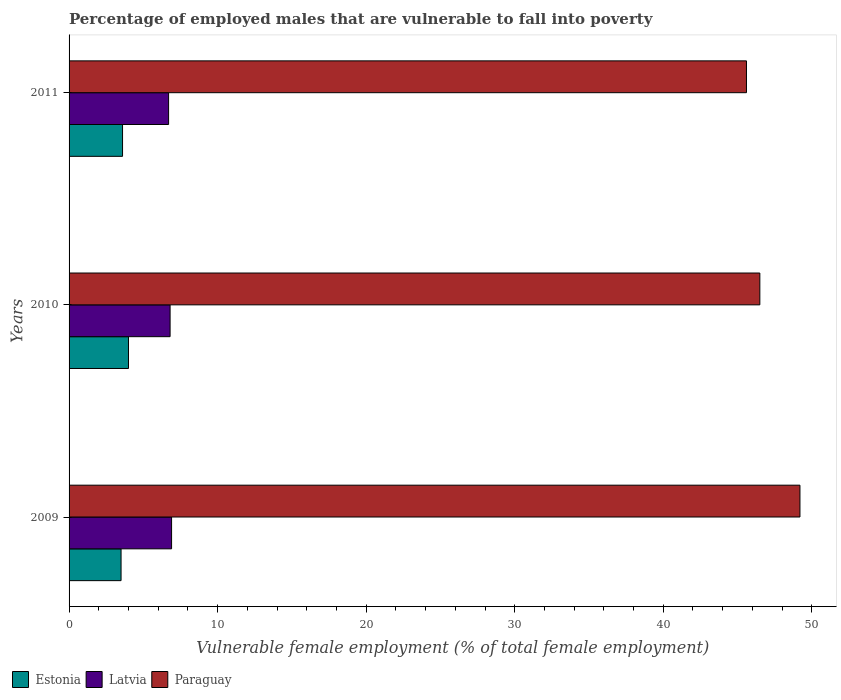How many different coloured bars are there?
Your answer should be very brief. 3. How many groups of bars are there?
Provide a succinct answer. 3. How many bars are there on the 2nd tick from the top?
Your answer should be compact. 3. How many bars are there on the 1st tick from the bottom?
Keep it short and to the point. 3. What is the percentage of employed males who are vulnerable to fall into poverty in Estonia in 2011?
Provide a short and direct response. 3.6. Across all years, what is the maximum percentage of employed males who are vulnerable to fall into poverty in Paraguay?
Offer a very short reply. 49.2. In which year was the percentage of employed males who are vulnerable to fall into poverty in Paraguay maximum?
Your answer should be very brief. 2009. In which year was the percentage of employed males who are vulnerable to fall into poverty in Estonia minimum?
Your answer should be compact. 2009. What is the total percentage of employed males who are vulnerable to fall into poverty in Latvia in the graph?
Your answer should be very brief. 20.4. What is the difference between the percentage of employed males who are vulnerable to fall into poverty in Latvia in 2010 and that in 2011?
Your answer should be very brief. 0.1. What is the difference between the percentage of employed males who are vulnerable to fall into poverty in Paraguay in 2010 and the percentage of employed males who are vulnerable to fall into poverty in Latvia in 2009?
Give a very brief answer. 39.6. What is the average percentage of employed males who are vulnerable to fall into poverty in Estonia per year?
Your response must be concise. 3.7. In the year 2009, what is the difference between the percentage of employed males who are vulnerable to fall into poverty in Estonia and percentage of employed males who are vulnerable to fall into poverty in Latvia?
Keep it short and to the point. -3.4. What is the ratio of the percentage of employed males who are vulnerable to fall into poverty in Latvia in 2009 to that in 2010?
Your answer should be very brief. 1.01. Is the percentage of employed males who are vulnerable to fall into poverty in Estonia in 2010 less than that in 2011?
Ensure brevity in your answer.  No. What is the difference between the highest and the second highest percentage of employed males who are vulnerable to fall into poverty in Latvia?
Ensure brevity in your answer.  0.1. What is the difference between the highest and the lowest percentage of employed males who are vulnerable to fall into poverty in Latvia?
Your response must be concise. 0.2. Is the sum of the percentage of employed males who are vulnerable to fall into poverty in Paraguay in 2010 and 2011 greater than the maximum percentage of employed males who are vulnerable to fall into poverty in Estonia across all years?
Provide a succinct answer. Yes. What does the 3rd bar from the top in 2010 represents?
Provide a short and direct response. Estonia. What does the 1st bar from the bottom in 2010 represents?
Provide a short and direct response. Estonia. How many years are there in the graph?
Offer a terse response. 3. Are the values on the major ticks of X-axis written in scientific E-notation?
Keep it short and to the point. No. Does the graph contain grids?
Provide a succinct answer. No. What is the title of the graph?
Ensure brevity in your answer.  Percentage of employed males that are vulnerable to fall into poverty. Does "Switzerland" appear as one of the legend labels in the graph?
Keep it short and to the point. No. What is the label or title of the X-axis?
Make the answer very short. Vulnerable female employment (% of total female employment). What is the Vulnerable female employment (% of total female employment) of Latvia in 2009?
Your response must be concise. 6.9. What is the Vulnerable female employment (% of total female employment) of Paraguay in 2009?
Your answer should be compact. 49.2. What is the Vulnerable female employment (% of total female employment) of Estonia in 2010?
Offer a very short reply. 4. What is the Vulnerable female employment (% of total female employment) in Latvia in 2010?
Offer a terse response. 6.8. What is the Vulnerable female employment (% of total female employment) in Paraguay in 2010?
Your answer should be very brief. 46.5. What is the Vulnerable female employment (% of total female employment) in Estonia in 2011?
Keep it short and to the point. 3.6. What is the Vulnerable female employment (% of total female employment) of Latvia in 2011?
Your answer should be very brief. 6.7. What is the Vulnerable female employment (% of total female employment) in Paraguay in 2011?
Give a very brief answer. 45.6. Across all years, what is the maximum Vulnerable female employment (% of total female employment) in Latvia?
Keep it short and to the point. 6.9. Across all years, what is the maximum Vulnerable female employment (% of total female employment) in Paraguay?
Your answer should be very brief. 49.2. Across all years, what is the minimum Vulnerable female employment (% of total female employment) of Estonia?
Provide a short and direct response. 3.5. Across all years, what is the minimum Vulnerable female employment (% of total female employment) in Latvia?
Give a very brief answer. 6.7. Across all years, what is the minimum Vulnerable female employment (% of total female employment) in Paraguay?
Your response must be concise. 45.6. What is the total Vulnerable female employment (% of total female employment) of Latvia in the graph?
Ensure brevity in your answer.  20.4. What is the total Vulnerable female employment (% of total female employment) of Paraguay in the graph?
Make the answer very short. 141.3. What is the difference between the Vulnerable female employment (% of total female employment) in Latvia in 2009 and that in 2010?
Your response must be concise. 0.1. What is the difference between the Vulnerable female employment (% of total female employment) in Latvia in 2009 and that in 2011?
Your answer should be compact. 0.2. What is the difference between the Vulnerable female employment (% of total female employment) of Paraguay in 2009 and that in 2011?
Your answer should be very brief. 3.6. What is the difference between the Vulnerable female employment (% of total female employment) of Estonia in 2010 and that in 2011?
Offer a terse response. 0.4. What is the difference between the Vulnerable female employment (% of total female employment) of Latvia in 2010 and that in 2011?
Keep it short and to the point. 0.1. What is the difference between the Vulnerable female employment (% of total female employment) of Estonia in 2009 and the Vulnerable female employment (% of total female employment) of Latvia in 2010?
Offer a very short reply. -3.3. What is the difference between the Vulnerable female employment (% of total female employment) of Estonia in 2009 and the Vulnerable female employment (% of total female employment) of Paraguay in 2010?
Give a very brief answer. -43. What is the difference between the Vulnerable female employment (% of total female employment) of Latvia in 2009 and the Vulnerable female employment (% of total female employment) of Paraguay in 2010?
Ensure brevity in your answer.  -39.6. What is the difference between the Vulnerable female employment (% of total female employment) of Estonia in 2009 and the Vulnerable female employment (% of total female employment) of Latvia in 2011?
Keep it short and to the point. -3.2. What is the difference between the Vulnerable female employment (% of total female employment) of Estonia in 2009 and the Vulnerable female employment (% of total female employment) of Paraguay in 2011?
Offer a terse response. -42.1. What is the difference between the Vulnerable female employment (% of total female employment) of Latvia in 2009 and the Vulnerable female employment (% of total female employment) of Paraguay in 2011?
Offer a very short reply. -38.7. What is the difference between the Vulnerable female employment (% of total female employment) in Estonia in 2010 and the Vulnerable female employment (% of total female employment) in Paraguay in 2011?
Give a very brief answer. -41.6. What is the difference between the Vulnerable female employment (% of total female employment) in Latvia in 2010 and the Vulnerable female employment (% of total female employment) in Paraguay in 2011?
Offer a terse response. -38.8. What is the average Vulnerable female employment (% of total female employment) of Estonia per year?
Keep it short and to the point. 3.7. What is the average Vulnerable female employment (% of total female employment) in Paraguay per year?
Your answer should be compact. 47.1. In the year 2009, what is the difference between the Vulnerable female employment (% of total female employment) of Estonia and Vulnerable female employment (% of total female employment) of Paraguay?
Give a very brief answer. -45.7. In the year 2009, what is the difference between the Vulnerable female employment (% of total female employment) of Latvia and Vulnerable female employment (% of total female employment) of Paraguay?
Provide a succinct answer. -42.3. In the year 2010, what is the difference between the Vulnerable female employment (% of total female employment) of Estonia and Vulnerable female employment (% of total female employment) of Paraguay?
Give a very brief answer. -42.5. In the year 2010, what is the difference between the Vulnerable female employment (% of total female employment) of Latvia and Vulnerable female employment (% of total female employment) of Paraguay?
Your response must be concise. -39.7. In the year 2011, what is the difference between the Vulnerable female employment (% of total female employment) in Estonia and Vulnerable female employment (% of total female employment) in Latvia?
Offer a terse response. -3.1. In the year 2011, what is the difference between the Vulnerable female employment (% of total female employment) of Estonia and Vulnerable female employment (% of total female employment) of Paraguay?
Give a very brief answer. -42. In the year 2011, what is the difference between the Vulnerable female employment (% of total female employment) in Latvia and Vulnerable female employment (% of total female employment) in Paraguay?
Your answer should be compact. -38.9. What is the ratio of the Vulnerable female employment (% of total female employment) of Latvia in 2009 to that in 2010?
Provide a short and direct response. 1.01. What is the ratio of the Vulnerable female employment (% of total female employment) of Paraguay in 2009 to that in 2010?
Make the answer very short. 1.06. What is the ratio of the Vulnerable female employment (% of total female employment) of Estonia in 2009 to that in 2011?
Ensure brevity in your answer.  0.97. What is the ratio of the Vulnerable female employment (% of total female employment) of Latvia in 2009 to that in 2011?
Offer a very short reply. 1.03. What is the ratio of the Vulnerable female employment (% of total female employment) of Paraguay in 2009 to that in 2011?
Provide a short and direct response. 1.08. What is the ratio of the Vulnerable female employment (% of total female employment) of Latvia in 2010 to that in 2011?
Keep it short and to the point. 1.01. What is the ratio of the Vulnerable female employment (% of total female employment) in Paraguay in 2010 to that in 2011?
Keep it short and to the point. 1.02. What is the difference between the highest and the second highest Vulnerable female employment (% of total female employment) of Latvia?
Your answer should be compact. 0.1. What is the difference between the highest and the second highest Vulnerable female employment (% of total female employment) in Paraguay?
Your answer should be compact. 2.7. What is the difference between the highest and the lowest Vulnerable female employment (% of total female employment) in Latvia?
Ensure brevity in your answer.  0.2. What is the difference between the highest and the lowest Vulnerable female employment (% of total female employment) of Paraguay?
Your response must be concise. 3.6. 